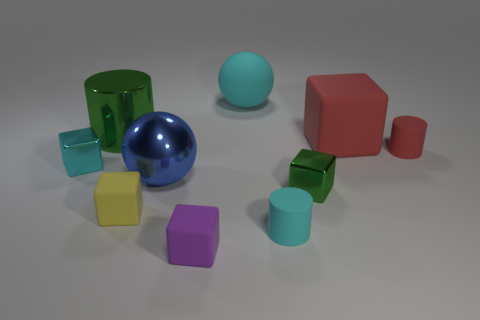Subtract all small rubber cylinders. How many cylinders are left? 1 Subtract all purple cubes. How many cubes are left? 4 Subtract all balls. How many objects are left? 8 Subtract all blue blocks. Subtract all yellow cylinders. How many blocks are left? 5 Subtract all brown balls. Subtract all large blue shiny spheres. How many objects are left? 9 Add 3 large blue balls. How many large blue balls are left? 4 Add 5 large green metal cylinders. How many large green metal cylinders exist? 6 Subtract 1 cyan cubes. How many objects are left? 9 